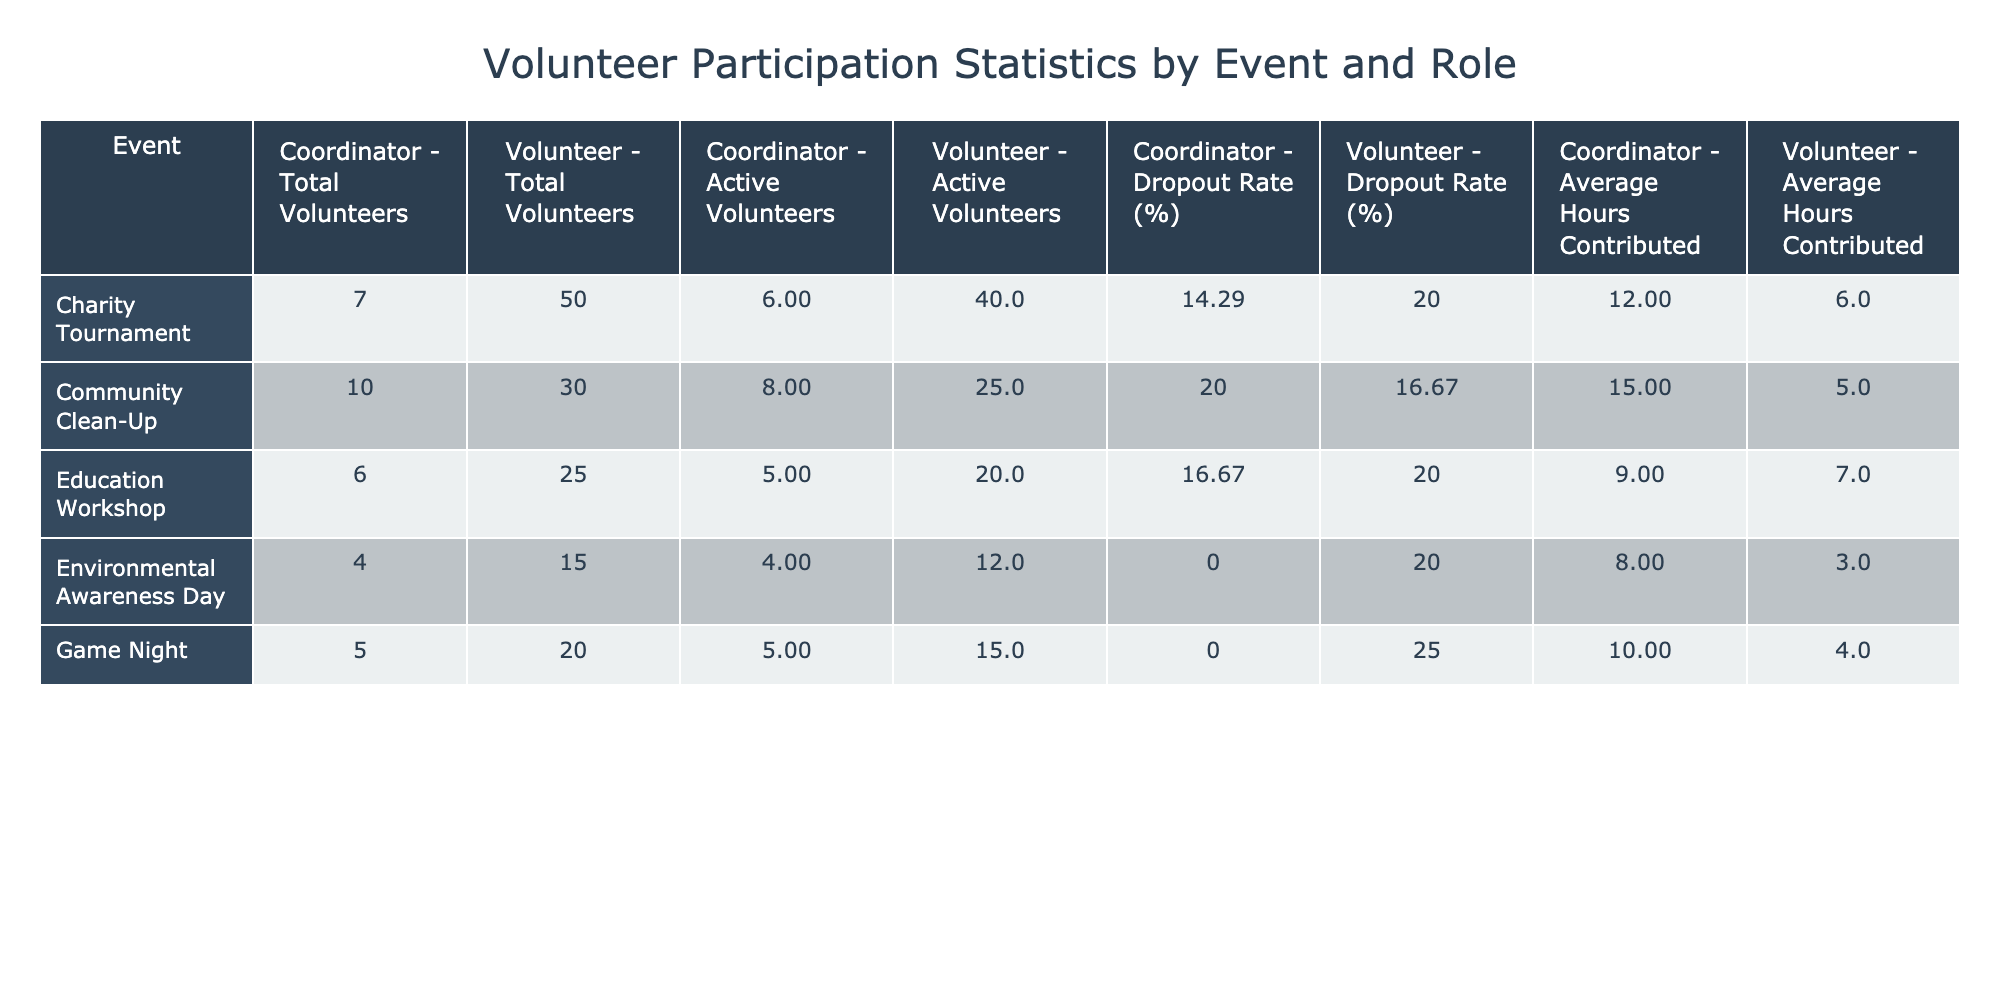What is the total number of volunteers for the Game Night event? Looking at the row for the Game Night event, under the 'Total Volunteers' column for 'Volunteer,' the value is 20. This indicates that there are a total of 20 volunteers for this event.
Answer: 20 What is the dropout rate for the Charity Tournament's volunteers? In the Charity Tournament row, the 'Dropout Rate (%)' for 'Volunteer' is listed as 20. This value tells us that 20% of the volunteers dropped out for this particular event.
Answer: 20 Which event had the highest average hours contributed by volunteers? Comparing the 'Average Hours Contributed' for each volunteer role, the Community Clean-Up (5 hours) has the highest average among the volunteer roles. The average hours for the coordinator is also highest at 15 hours. Therefore, the Community Clean-Up has the highest average.
Answer: Community Clean-Up What is the difference in active volunteers between the Community Clean-Up and the Charity Tournament? The active volunteers for Community Clean-Up (Volunteer) is 25 and for Charity Tournament (Volunteer) is 40. The difference is calculated as 40 - 25 = 15, meaning there are 15 more active volunteers in the Charity Tournament.
Answer: 15 Do all coordinators have an active volunteer count less than or equal to their total volunteers? By checking each coordinator's active volunteer count against the total volunteers, all coordinators (Community Clean-Up, Game Night, Charity Tournament, Environmental Awareness Day, and Education Workshop) have active counts that do not exceed their total volunteers. Therefore, the statement is true.
Answer: Yes For which event is the dropout rate the lowest? Analyzing the 'Dropout Rate (%)' for each event, Game Night has a dropout rate of 0 for its coordinator role. This is the lowest compared to other events where dropout rates range from 14.29 to 25%.
Answer: Game Night What is the average number of total volunteers across all events? To find this, we add up the total volunteers (10 + 30 + 5 + 20 + 7 + 50 + 4 + 15 + 6 + 25) = 177. There are 10 events in total, thus the average is calculated as 177 / 10 = 17.7, which represents the average total volunteers across events.
Answer: 17.7 How many volunteers participated (both active and total) in the Education Workshop? In the Education Workshop row, total volunteers are 25, and active volunteers are 20. The total participation can be calculated as 25 + 20 = 45, combining both active and total volunteers.
Answer: 45 